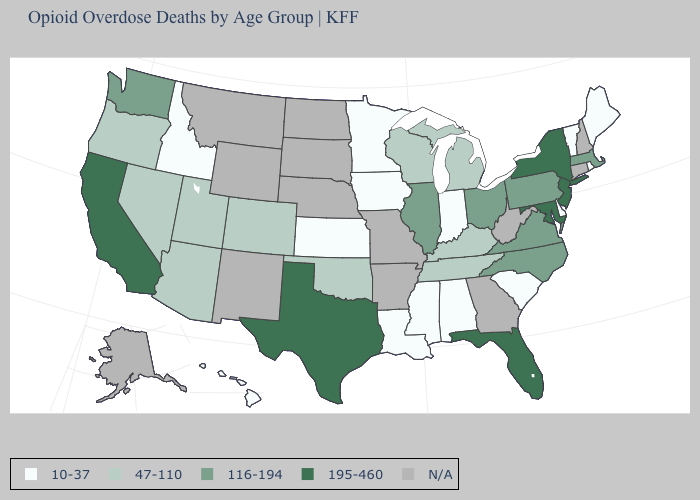Is the legend a continuous bar?
Be succinct. No. Name the states that have a value in the range 47-110?
Write a very short answer. Arizona, Colorado, Kentucky, Michigan, Nevada, Oklahoma, Oregon, Tennessee, Utah, Wisconsin. What is the value of Vermont?
Be succinct. 10-37. What is the highest value in the USA?
Write a very short answer. 195-460. Among the states that border North Dakota , which have the lowest value?
Concise answer only. Minnesota. Among the states that border Alabama , does Florida have the lowest value?
Quick response, please. No. Does the first symbol in the legend represent the smallest category?
Write a very short answer. Yes. What is the value of Texas?
Be succinct. 195-460. Does Maine have the lowest value in the Northeast?
Keep it brief. Yes. Name the states that have a value in the range 116-194?
Keep it brief. Illinois, Massachusetts, North Carolina, Ohio, Pennsylvania, Virginia, Washington. Does Pennsylvania have the highest value in the Northeast?
Keep it brief. No. Does New York have the highest value in the USA?
Write a very short answer. Yes. Name the states that have a value in the range 47-110?
Write a very short answer. Arizona, Colorado, Kentucky, Michigan, Nevada, Oklahoma, Oregon, Tennessee, Utah, Wisconsin. 